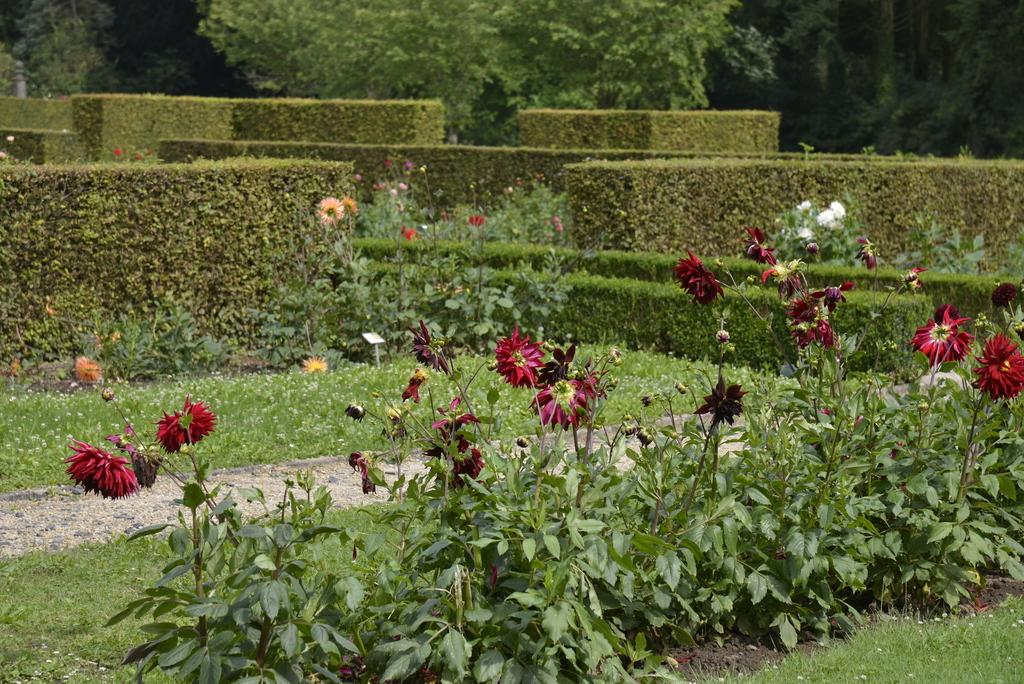What type of vegetation can be seen in the image? There is grass, plants, flowers, and trees in the image. Can you describe the different types of plants in the image? The image contains grass, plants, flowers, and trees. What might be the purpose of the trees in the image? The trees in the image provide shade, habitat for wildlife, and contribute to the overall aesthetic of the scene. How many steps are being used to water the flowers in the image? There are no steps present in the image, and the flowers are not being watered. 